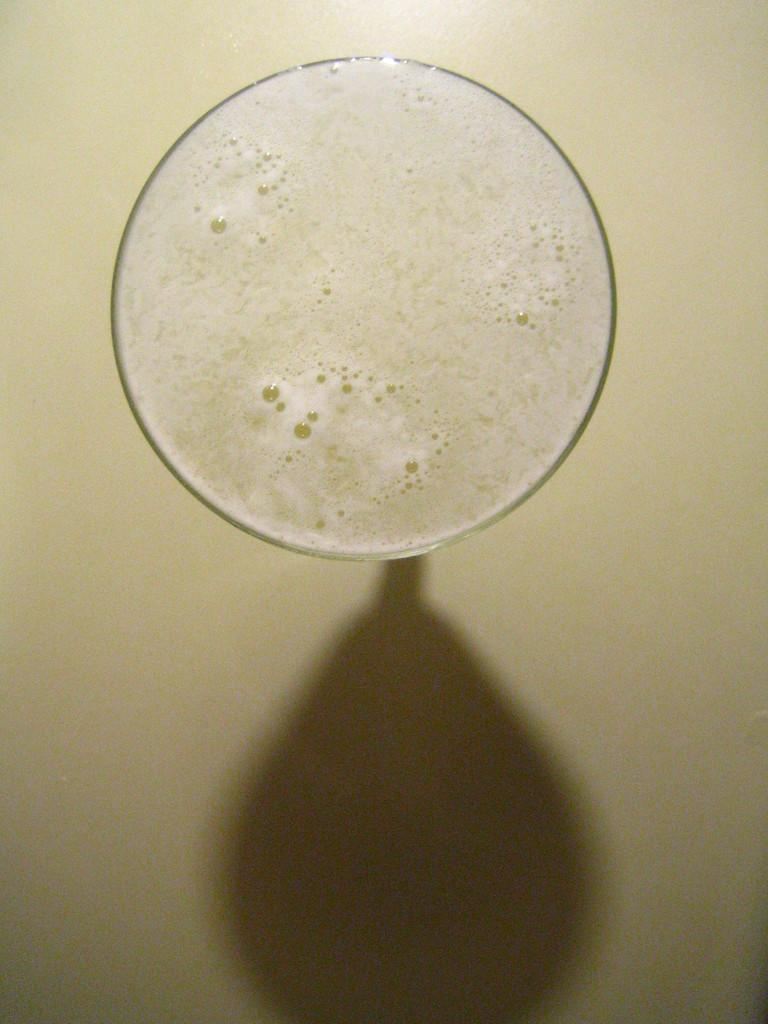What is in the glass that is visible in the image? There is a drink in a glass in the image. What else can be seen in the image related to the glass? There is a shadow of the glass on the floor in the image. How many cattle are present in the image? There are no cattle present in the image. What type of beast can be seen in the image? There are no beasts present in the image. 